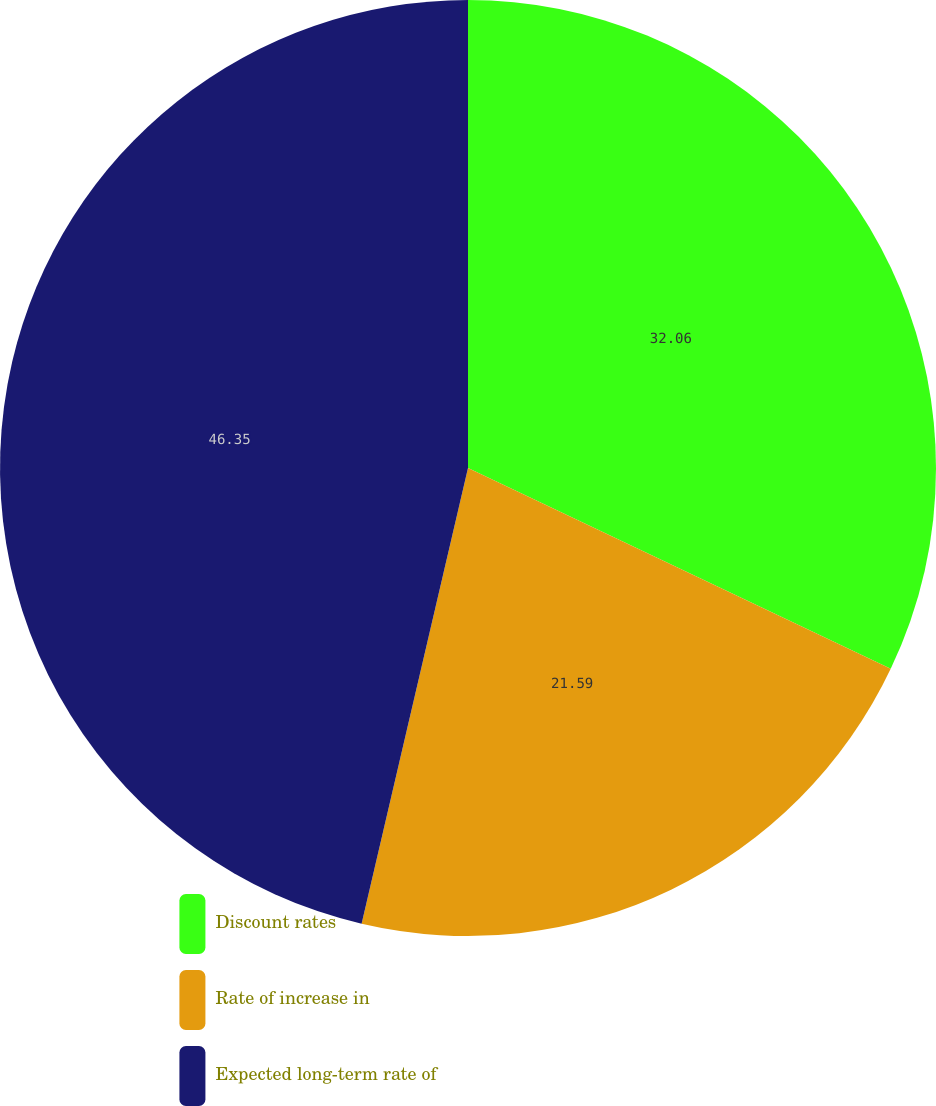<chart> <loc_0><loc_0><loc_500><loc_500><pie_chart><fcel>Discount rates<fcel>Rate of increase in<fcel>Expected long-term rate of<nl><fcel>32.06%<fcel>21.59%<fcel>46.35%<nl></chart> 